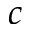Convert formula to latex. <formula><loc_0><loc_0><loc_500><loc_500>c</formula> 